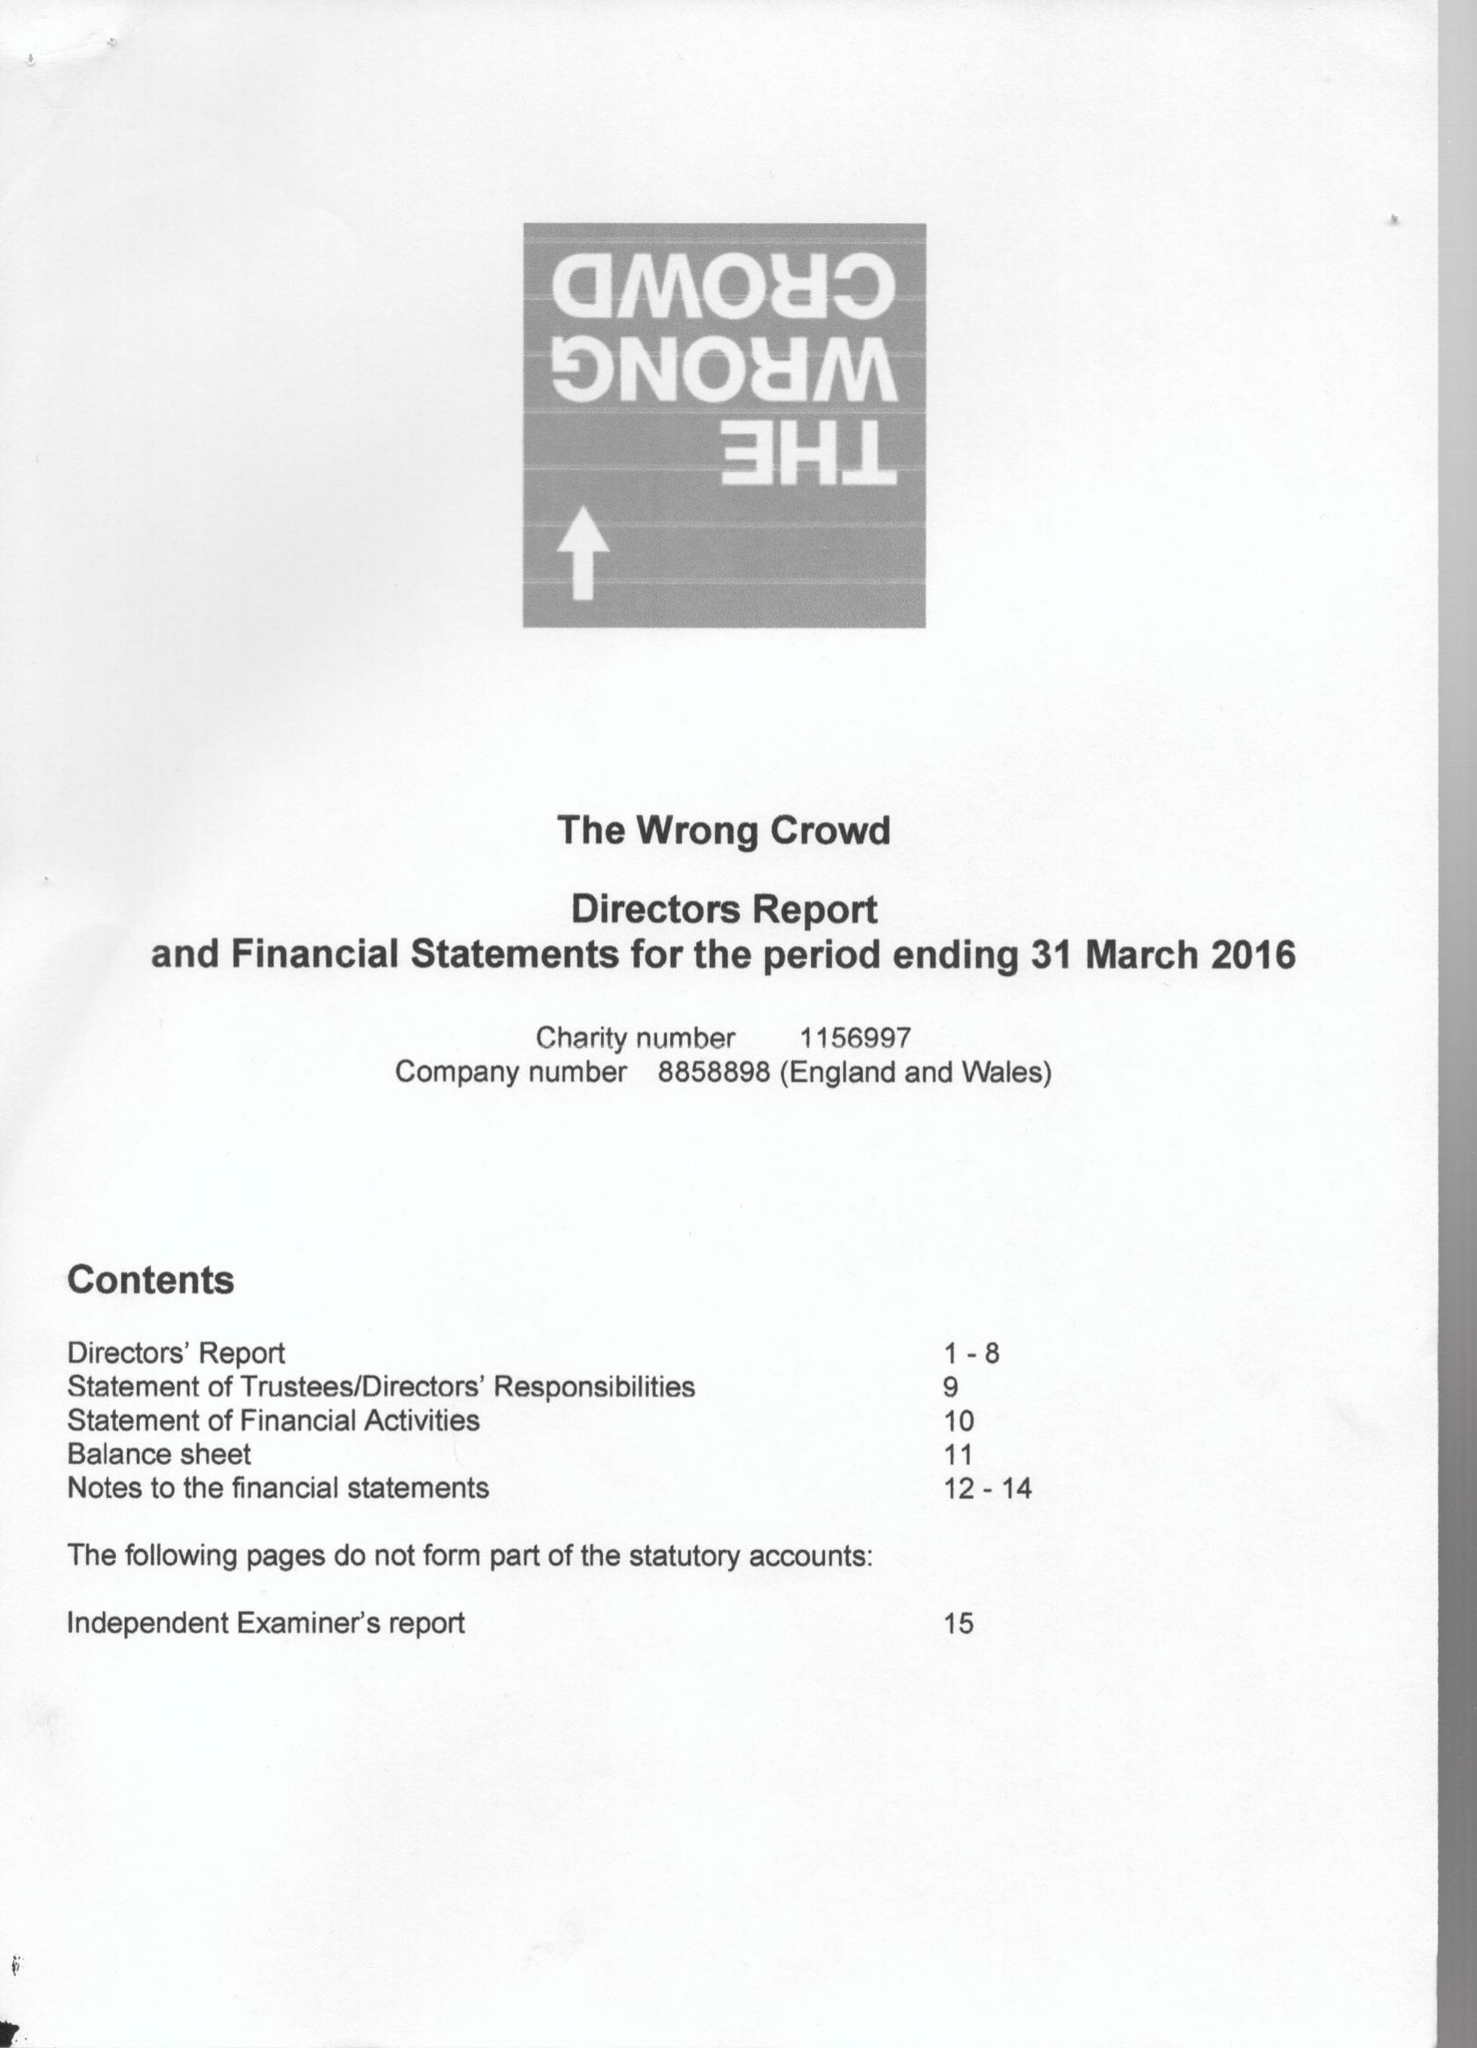What is the value for the spending_annually_in_british_pounds?
Answer the question using a single word or phrase. 215015.00 